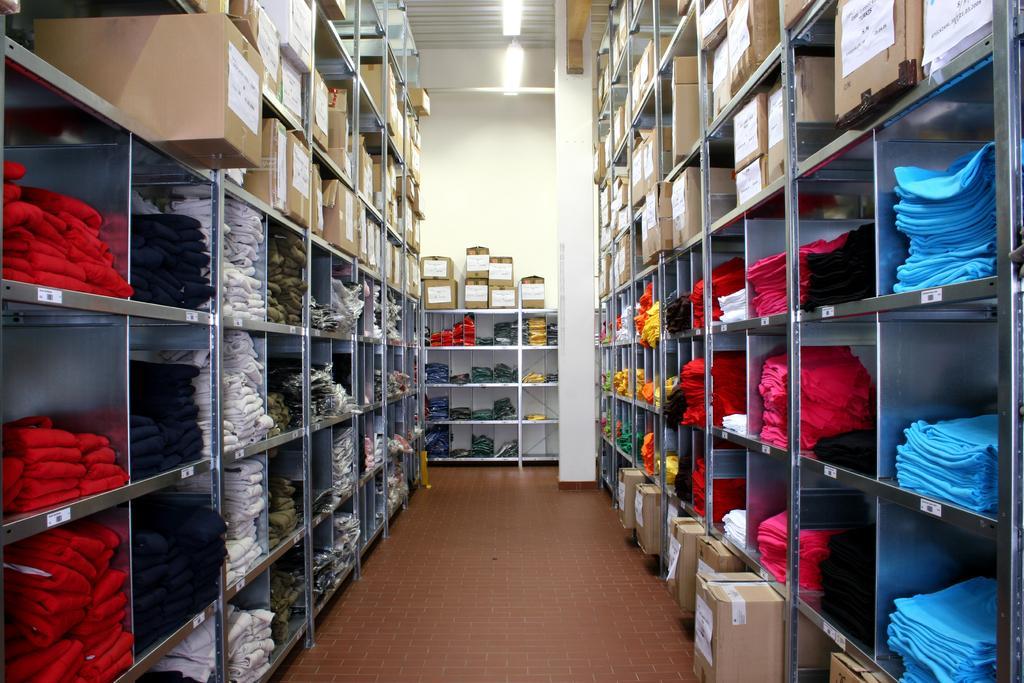Can you describe this image briefly? In this image I can see clothes and cartons in the shelves. There are lights at the top. 